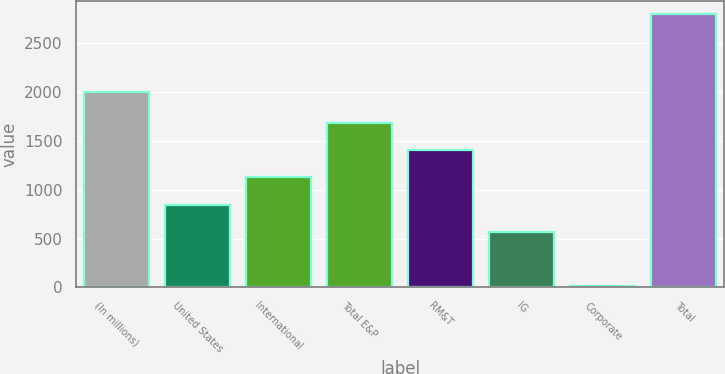Convert chart to OTSL. <chart><loc_0><loc_0><loc_500><loc_500><bar_chart><fcel>(In millions)<fcel>United States<fcel>International<fcel>Total E&P<fcel>RM&T<fcel>IG<fcel>Corporate<fcel>Total<nl><fcel>2005<fcel>848.8<fcel>1126.6<fcel>1682.2<fcel>1404.4<fcel>571<fcel>18<fcel>2796<nl></chart> 